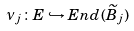<formula> <loc_0><loc_0><loc_500><loc_500>\nu _ { j } \colon E \hookrightarrow E n d ( \widetilde { B } _ { j } )</formula> 